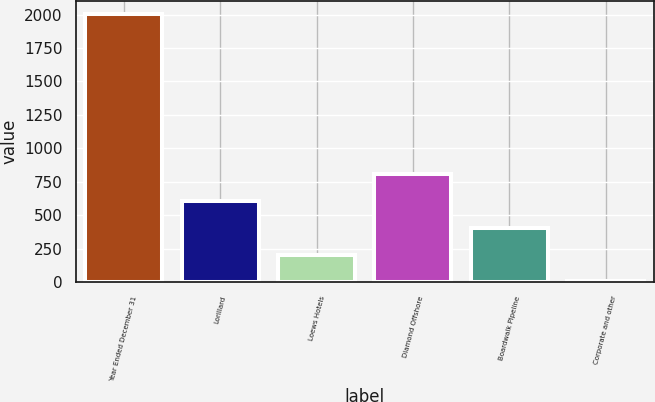Convert chart to OTSL. <chart><loc_0><loc_0><loc_500><loc_500><bar_chart><fcel>Year Ended December 31<fcel>Lorillard<fcel>Loews Hotels<fcel>Diamond Offshore<fcel>Boardwalk Pipeline<fcel>Corporate and other<nl><fcel>2004<fcel>604.98<fcel>205.26<fcel>804.84<fcel>405.12<fcel>5.4<nl></chart> 